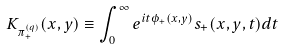<formula> <loc_0><loc_0><loc_500><loc_500>K _ { \pi ^ { ( q ) } _ { + } } ( x , y ) \equiv \int ^ { \infty } _ { 0 } e ^ { i t \phi _ { + } ( x , y ) } s _ { + } ( x , y , t ) d t</formula> 